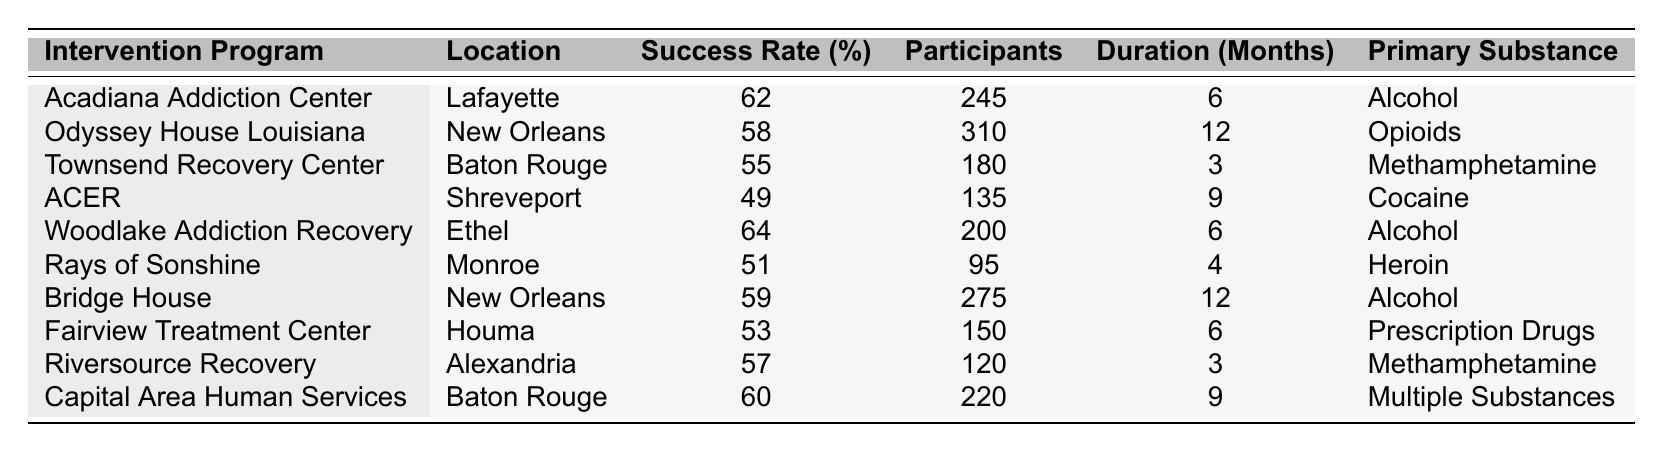What is the success rate of the Acadiana Addiction Center? The Acadiana Addiction Center has a success rate of 62%, as indicated in the table.
Answer: 62% Which intervention program has the highest success rate? The Woodlake Addiction Recovery program has the highest success rate at 64%, as shown in the table under the success rates.
Answer: 64% How many participants were involved in the Odyssey House Louisiana program? According to the table, the Odyssey House Louisiana program had 310 participants.
Answer: 310 Is the success rate of the Townsend Recovery Center lower than that of the Fairview Treatment Center? The Townsend Recovery Center has a success rate of 55%, while the Fairview Treatment Center has a success rate of 53%. Since 55% is higher than 53%, the statement is false.
Answer: No What is the average success rate of the programs located in New Orleans? The success rates for the programs in New Orleans are 58% (Odyssey House Louisiana) and 59% (Bridge House). The average is calculated as (58 + 59) / 2 = 58.5%.
Answer: 58.5% How many programs have a success rate greater than 55%? The programs with a success rate greater than 55% are Acadiana Addiction Center (62%), Woodlake Addiction Recovery (64%), Odyssey House Louisiana (58%), and Bridge House (59%), totaling four programs.
Answer: 4 What is the primary substance addressed by the Riversource Recovery program? The Riversource Recovery program addresses Methamphetamine, as directly stated in the table.
Answer: Methamphetamine Which program had the least number of participants, and what was its success rate? The program with the least number of participants is Rays of Sonshine, which had 95 participants and a success rate of 51%.
Answer: Rays of Sonshine, 51% If you combine the success rates of all the programs in Baton Rouge, what is the average success rate? The success rates for the Baton Rouge programs are 55% (Townsend Recovery Center) and 60% (Capital Area Human Services). The average is (55 + 60) / 2 = 57.5%.
Answer: 57.5% Are there more programs focused on Alcohol than other substances? There are three programs focused on Alcohol (Acadiana Addiction Center, Woodlake Addiction Recovery, Bridge House) compared to others, so the statement is true.
Answer: Yes 